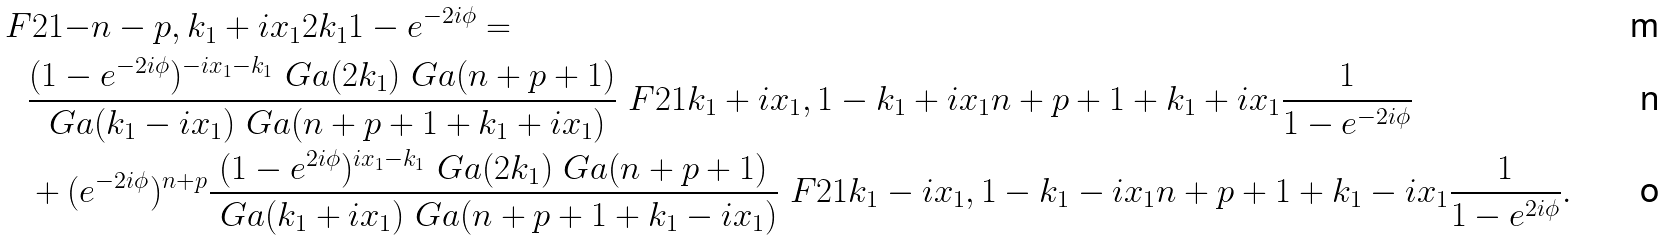<formula> <loc_0><loc_0><loc_500><loc_500>& \ F { 2 } { 1 } { - n - p , k _ { 1 } + i x _ { 1 } } { 2 k _ { 1 } } { 1 - e ^ { - 2 i \phi } } = \\ & \quad \frac { ( 1 - e ^ { - 2 i \phi } ) ^ { - i x _ { 1 } - k _ { 1 } } \ G a ( 2 k _ { 1 } ) \ G a ( n + p + 1 ) } { \ G a ( k _ { 1 } - i x _ { 1 } ) \ G a ( n + p + 1 + k _ { 1 } + i x _ { 1 } ) } \ F { 2 } { 1 } { k _ { 1 } + i x _ { 1 } , 1 - k _ { 1 } + i x _ { 1 } } { n + p + 1 + k _ { 1 } + i x _ { 1 } } { \frac { 1 } { 1 - e ^ { - 2 i \phi } } } \\ & \quad + ( e ^ { - 2 i \phi } ) ^ { n + p } \frac { ( 1 - e ^ { 2 i \phi } ) ^ { i x _ { 1 } - k _ { 1 } } \ G a ( 2 k _ { 1 } ) \ G a ( n + p + 1 ) } { \ G a ( k _ { 1 } + i x _ { 1 } ) \ G a ( n + p + 1 + k _ { 1 } - i x _ { 1 } ) } \ F { 2 } { 1 } { k _ { 1 } - i x _ { 1 } , 1 - k _ { 1 } - i x _ { 1 } } { n + p + 1 + k _ { 1 } - i x _ { 1 } } { \frac { 1 } { 1 - e ^ { 2 i \phi } } } .</formula> 